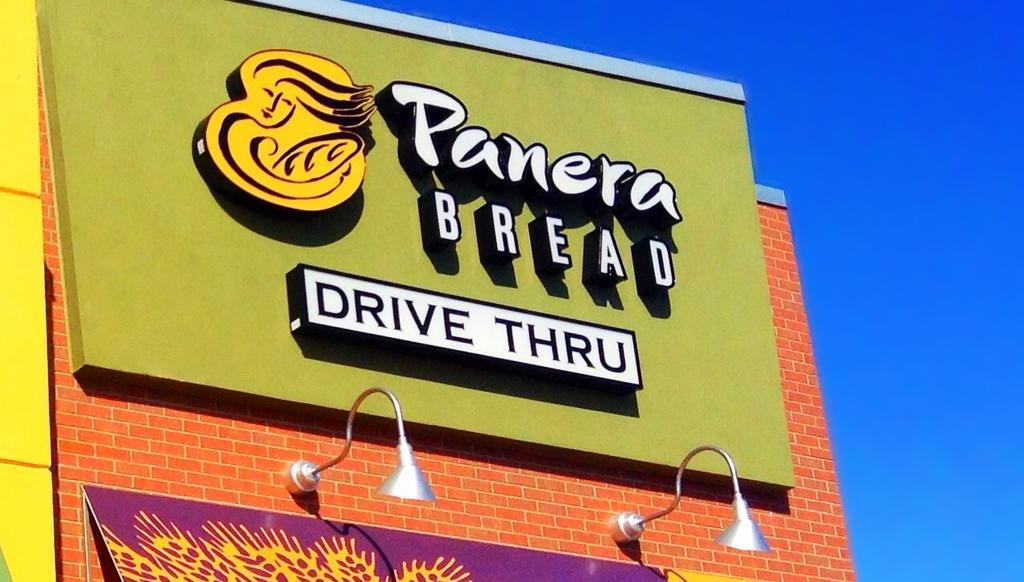Provide a one-sentence caption for the provided image. sign for panera bread drive thru above lights on colorful building. 